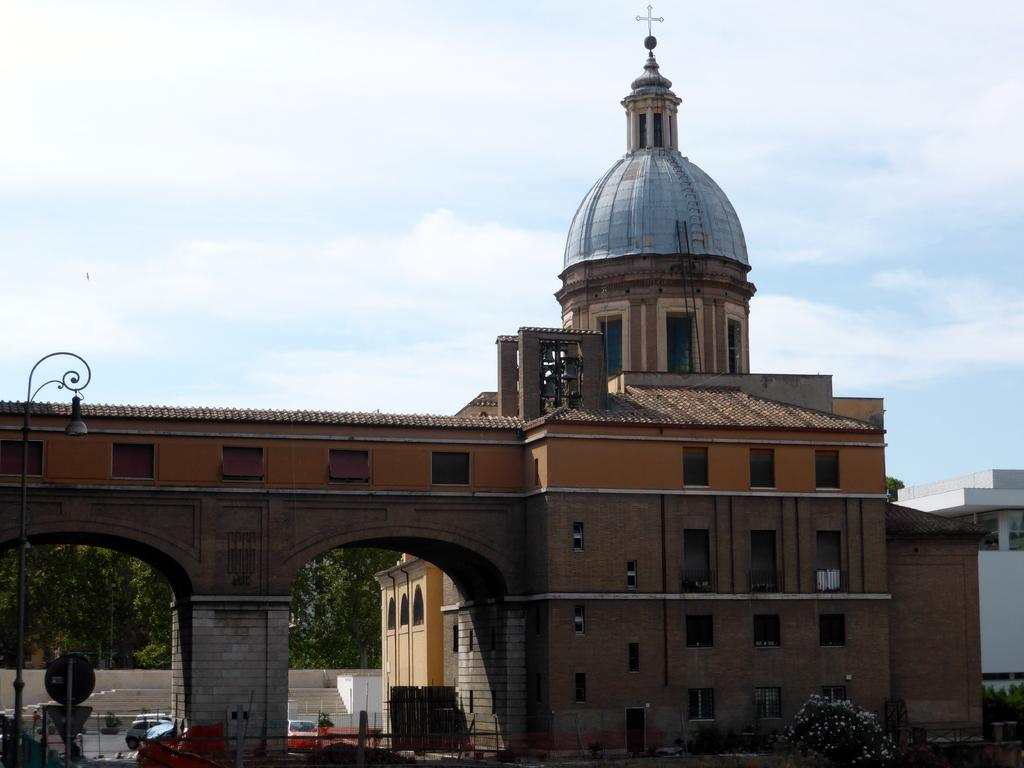What types of vehicles are at the bottom of the image? There are cars at the bottom of the image. What other objects can be seen at the bottom of the image? There are sign boards, street lights, and plants at the bottom of the image. What structure is located in the middle of the image? There is a building in the middle of the image. What is visible in the background of the image? The sky is visible in the background of the image, and there are clouds present. What is the rate of the land in the image? There is no mention of land or a rate in the image. What plot is being developed in the image? There is no plot or development project visible in the image. 